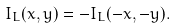<formula> <loc_0><loc_0><loc_500><loc_500>I _ { L } ( x , y ) = - I _ { L } ( - x , - y ) .</formula> 